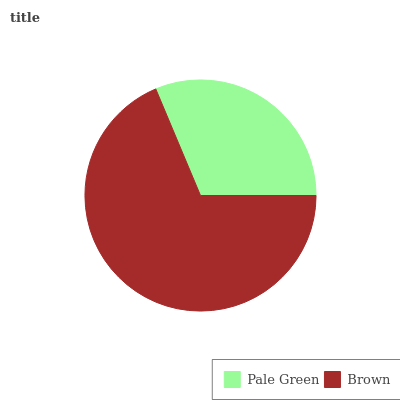Is Pale Green the minimum?
Answer yes or no. Yes. Is Brown the maximum?
Answer yes or no. Yes. Is Brown the minimum?
Answer yes or no. No. Is Brown greater than Pale Green?
Answer yes or no. Yes. Is Pale Green less than Brown?
Answer yes or no. Yes. Is Pale Green greater than Brown?
Answer yes or no. No. Is Brown less than Pale Green?
Answer yes or no. No. Is Brown the high median?
Answer yes or no. Yes. Is Pale Green the low median?
Answer yes or no. Yes. Is Pale Green the high median?
Answer yes or no. No. Is Brown the low median?
Answer yes or no. No. 